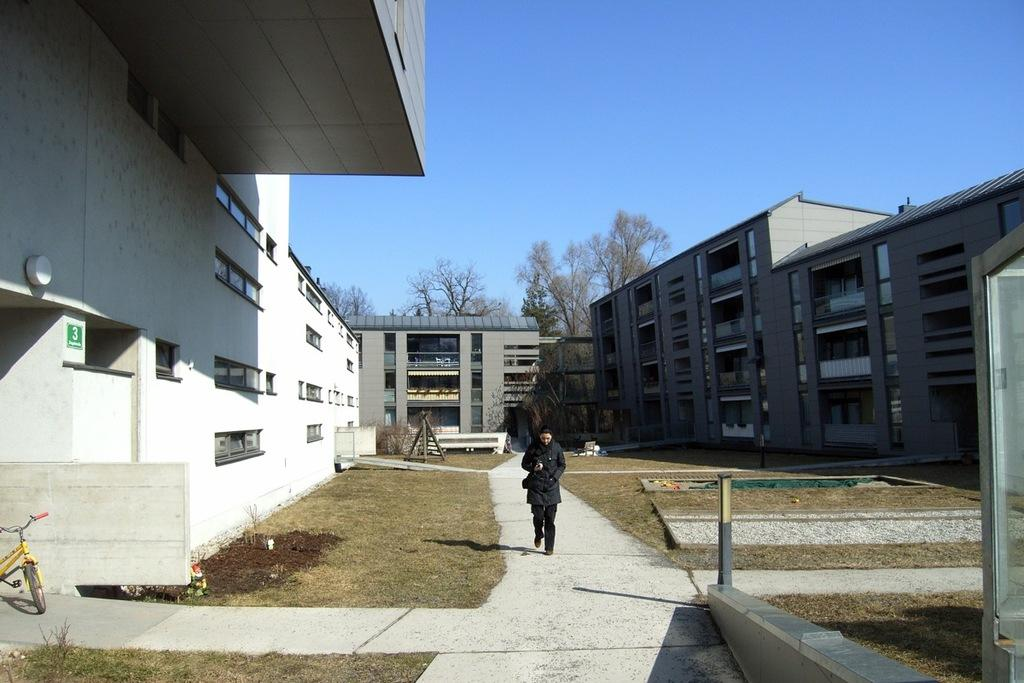Who is present in the image? There is a person in the image. What is the person wearing? The person is wearing a black dress. What is the person doing in the image? The person is walking on a pathway. What else can be seen in the image? There is a bicycle, grass, a building, trees, and the sky visible in the image. What type of sand can be seen in the image? There is no sand present in the image. 